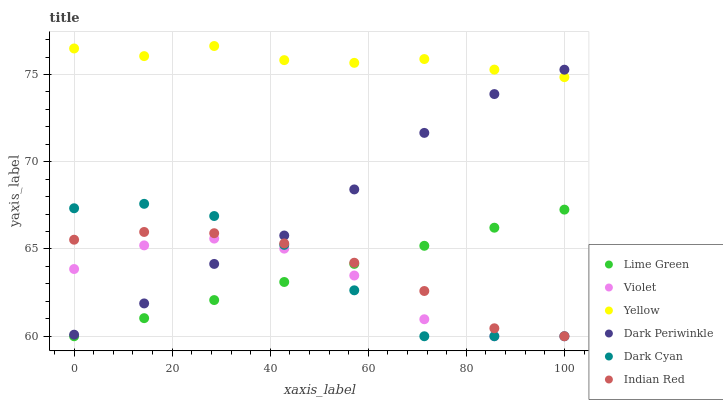Does Violet have the minimum area under the curve?
Answer yes or no. Yes. Does Yellow have the maximum area under the curve?
Answer yes or no. Yes. Does Indian Red have the minimum area under the curve?
Answer yes or no. No. Does Indian Red have the maximum area under the curve?
Answer yes or no. No. Is Lime Green the smoothest?
Answer yes or no. Yes. Is Violet the roughest?
Answer yes or no. Yes. Is Indian Red the smoothest?
Answer yes or no. No. Is Indian Red the roughest?
Answer yes or no. No. Does Indian Red have the lowest value?
Answer yes or no. Yes. Does Dark Periwinkle have the lowest value?
Answer yes or no. No. Does Yellow have the highest value?
Answer yes or no. Yes. Does Indian Red have the highest value?
Answer yes or no. No. Is Violet less than Yellow?
Answer yes or no. Yes. Is Yellow greater than Indian Red?
Answer yes or no. Yes. Does Violet intersect Dark Cyan?
Answer yes or no. Yes. Is Violet less than Dark Cyan?
Answer yes or no. No. Is Violet greater than Dark Cyan?
Answer yes or no. No. Does Violet intersect Yellow?
Answer yes or no. No. 